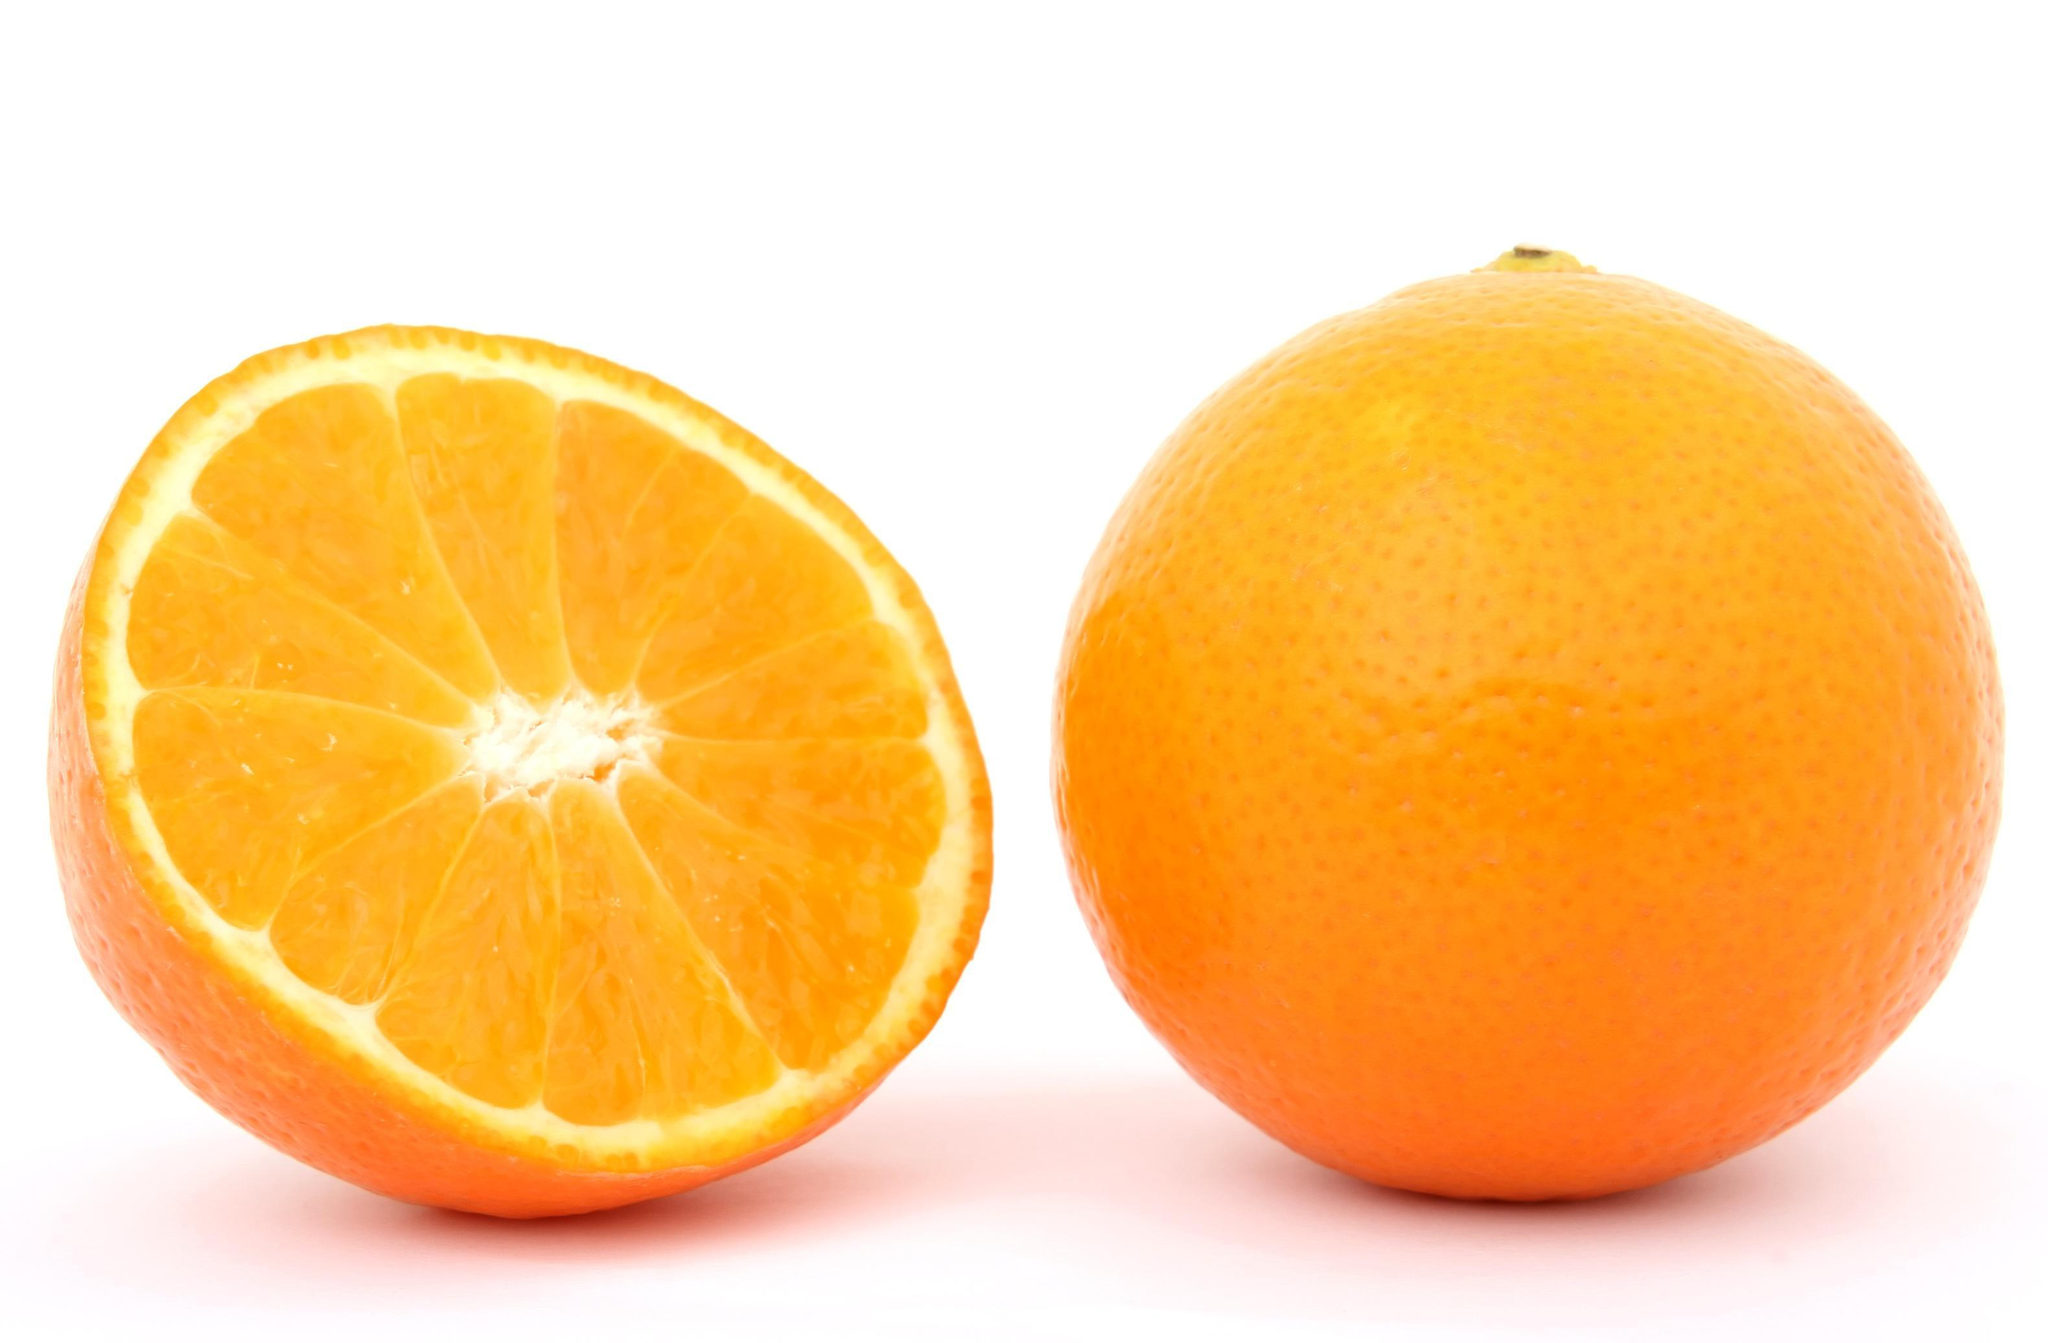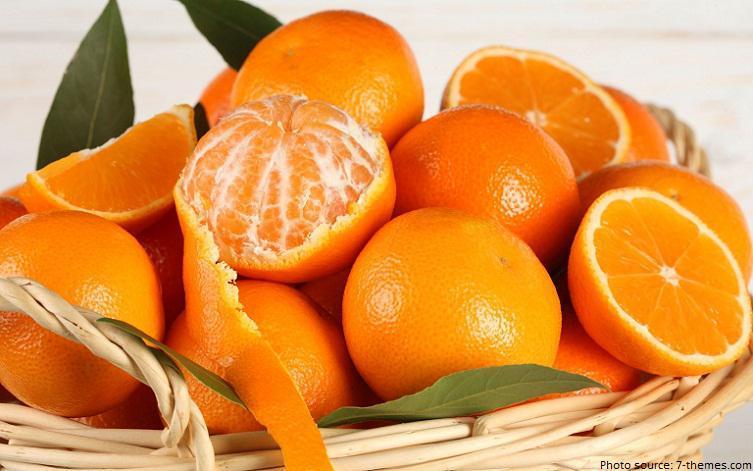The first image is the image on the left, the second image is the image on the right. For the images displayed, is the sentence "In at least one image there are three parallel orange leaves next to no more then three full oranges." factually correct? Answer yes or no. No. The first image is the image on the left, the second image is the image on the right. Considering the images on both sides, is "The left image contains only a half orange next to a whole orange, and the right image includes a half orange, orange wedge, whole orange, and green leaves." valid? Answer yes or no. Yes. 